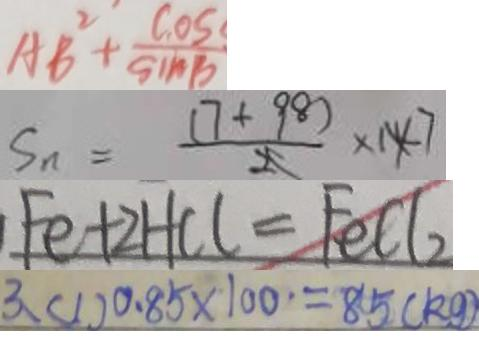<formula> <loc_0><loc_0><loc_500><loc_500>A B ^ { 2 } + \frac { \cos } { \sin B } 
 S _ { n } = \frac { ( 7 + 9 8 ) } { 2 } \times 1 4 7 
 F e + 2 H C l = F e C l _ { 2 } 
 3 、 ( 1 ) 0 . 8 5 \times 1 0 0 = 8 5 ( k g )</formula> 